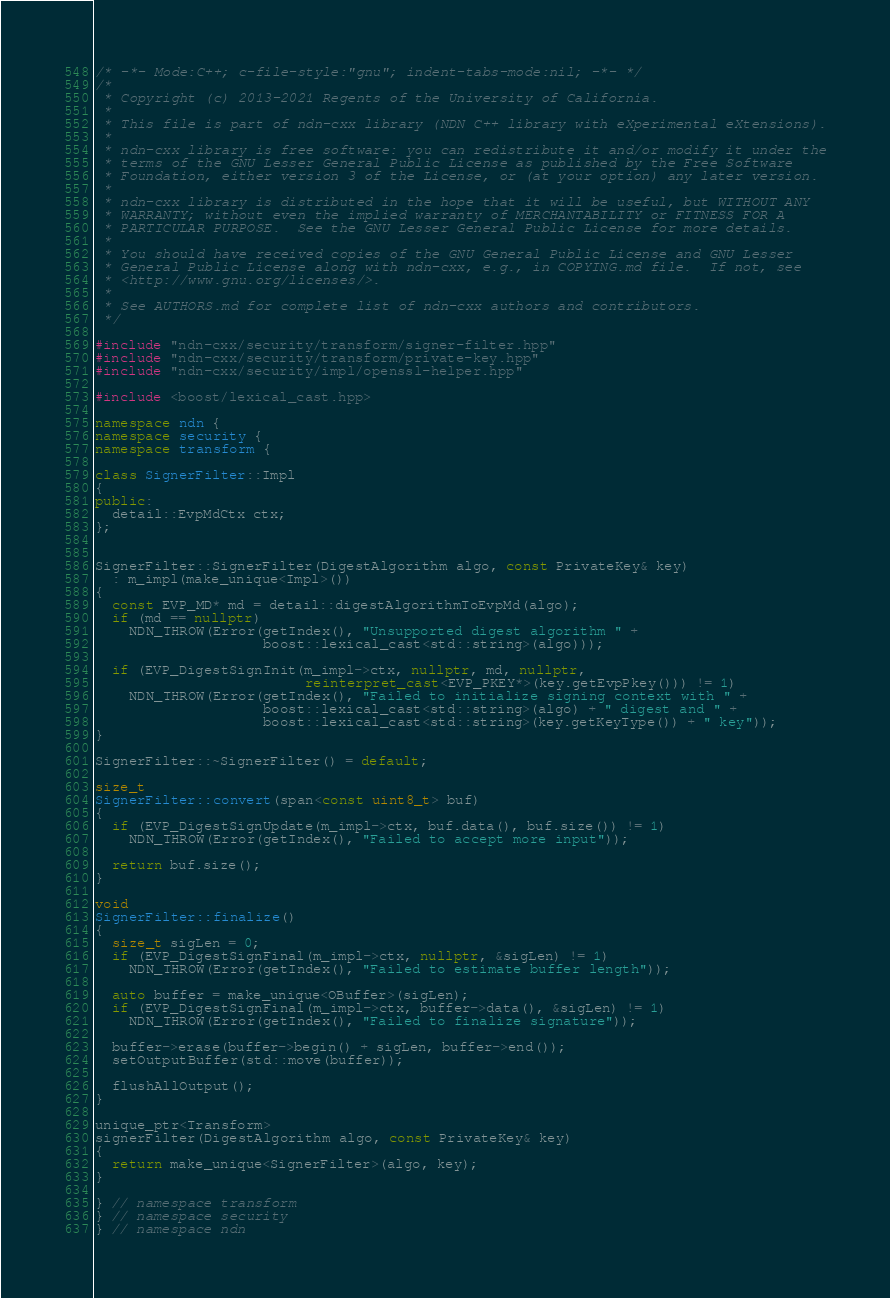<code> <loc_0><loc_0><loc_500><loc_500><_C++_>/* -*- Mode:C++; c-file-style:"gnu"; indent-tabs-mode:nil; -*- */
/*
 * Copyright (c) 2013-2021 Regents of the University of California.
 *
 * This file is part of ndn-cxx library (NDN C++ library with eXperimental eXtensions).
 *
 * ndn-cxx library is free software: you can redistribute it and/or modify it under the
 * terms of the GNU Lesser General Public License as published by the Free Software
 * Foundation, either version 3 of the License, or (at your option) any later version.
 *
 * ndn-cxx library is distributed in the hope that it will be useful, but WITHOUT ANY
 * WARRANTY; without even the implied warranty of MERCHANTABILITY or FITNESS FOR A
 * PARTICULAR PURPOSE.  See the GNU Lesser General Public License for more details.
 *
 * You should have received copies of the GNU General Public License and GNU Lesser
 * General Public License along with ndn-cxx, e.g., in COPYING.md file.  If not, see
 * <http://www.gnu.org/licenses/>.
 *
 * See AUTHORS.md for complete list of ndn-cxx authors and contributors.
 */

#include "ndn-cxx/security/transform/signer-filter.hpp"
#include "ndn-cxx/security/transform/private-key.hpp"
#include "ndn-cxx/security/impl/openssl-helper.hpp"

#include <boost/lexical_cast.hpp>

namespace ndn {
namespace security {
namespace transform {

class SignerFilter::Impl
{
public:
  detail::EvpMdCtx ctx;
};


SignerFilter::SignerFilter(DigestAlgorithm algo, const PrivateKey& key)
  : m_impl(make_unique<Impl>())
{
  const EVP_MD* md = detail::digestAlgorithmToEvpMd(algo);
  if (md == nullptr)
    NDN_THROW(Error(getIndex(), "Unsupported digest algorithm " +
                    boost::lexical_cast<std::string>(algo)));

  if (EVP_DigestSignInit(m_impl->ctx, nullptr, md, nullptr,
                         reinterpret_cast<EVP_PKEY*>(key.getEvpPkey())) != 1)
    NDN_THROW(Error(getIndex(), "Failed to initialize signing context with " +
                    boost::lexical_cast<std::string>(algo) + " digest and " +
                    boost::lexical_cast<std::string>(key.getKeyType()) + " key"));
}

SignerFilter::~SignerFilter() = default;

size_t
SignerFilter::convert(span<const uint8_t> buf)
{
  if (EVP_DigestSignUpdate(m_impl->ctx, buf.data(), buf.size()) != 1)
    NDN_THROW(Error(getIndex(), "Failed to accept more input"));

  return buf.size();
}

void
SignerFilter::finalize()
{
  size_t sigLen = 0;
  if (EVP_DigestSignFinal(m_impl->ctx, nullptr, &sigLen) != 1)
    NDN_THROW(Error(getIndex(), "Failed to estimate buffer length"));

  auto buffer = make_unique<OBuffer>(sigLen);
  if (EVP_DigestSignFinal(m_impl->ctx, buffer->data(), &sigLen) != 1)
    NDN_THROW(Error(getIndex(), "Failed to finalize signature"));

  buffer->erase(buffer->begin() + sigLen, buffer->end());
  setOutputBuffer(std::move(buffer));

  flushAllOutput();
}

unique_ptr<Transform>
signerFilter(DigestAlgorithm algo, const PrivateKey& key)
{
  return make_unique<SignerFilter>(algo, key);
}

} // namespace transform
} // namespace security
} // namespace ndn
</code> 